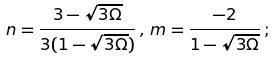Convert formula to latex. <formula><loc_0><loc_0><loc_500><loc_500>n = \frac { 3 - \sqrt { 3 \Omega } } { 3 ( 1 - \sqrt { 3 \Omega } ) } \, , \, m = \frac { - 2 } { 1 - \sqrt { 3 \Omega } } \, ;</formula> 